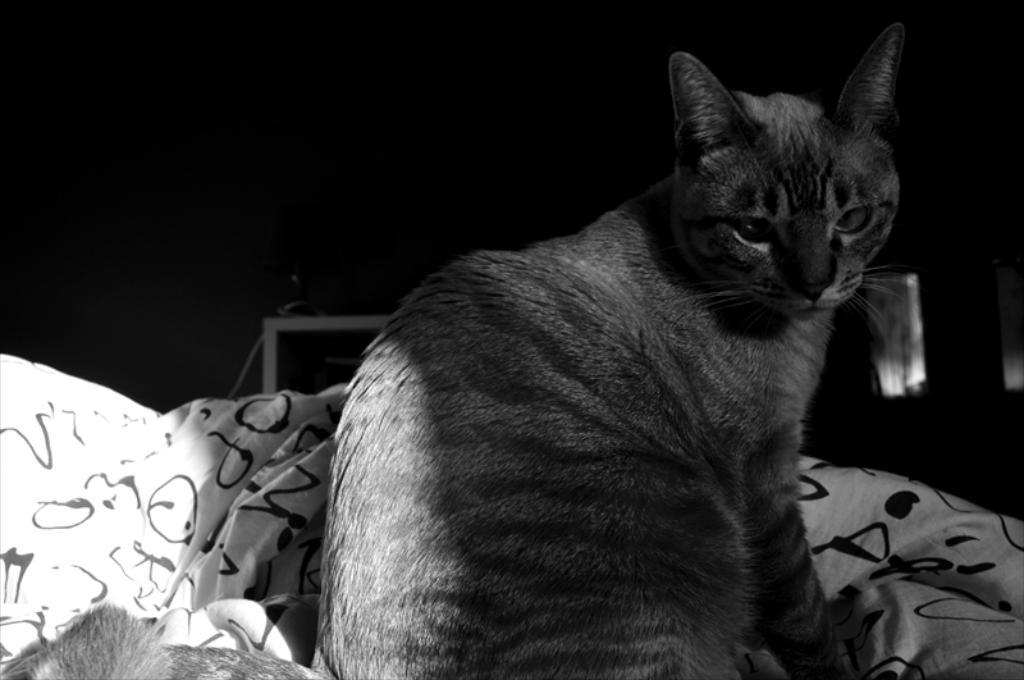What type of animal is in the image? There is a cat in the image. What object is present in the image besides the cat? There is a cloth in the image. How would you describe the overall appearance of the image? The background of the image is dark, and the image is black and white. What type of guitar can be seen in the image? There is no guitar present in the image; it features a cat and a cloth. How many wings are visible on the cat in the image? Cats do not have wings, so there are no wings visible on the cat in the image. 